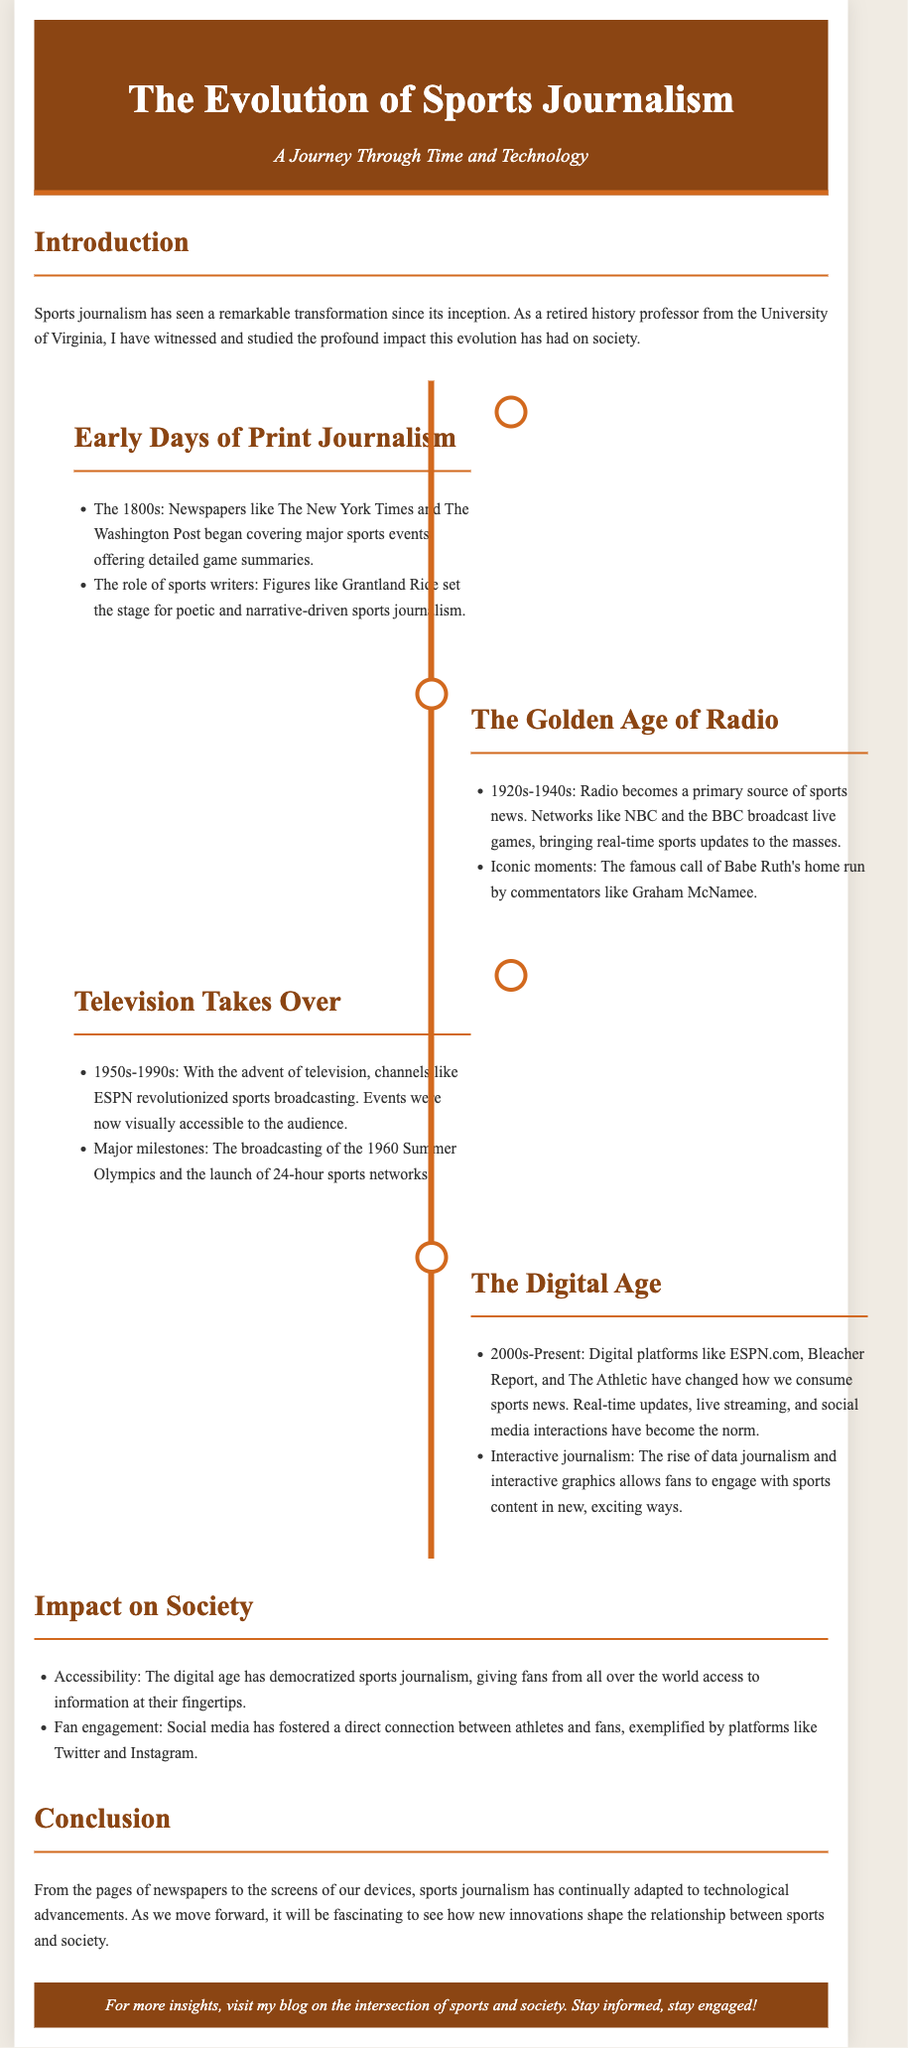What decade saw the rise of radio in sports journalism? The document states that the 1920s-1940s marked the period when radio became a primary source of sports news.
Answer: 1920s-1940s Who is noted for setting the stage for poetic sports journalism? The document mentions Grantland Rice as a key figure in early sports writing.
Answer: Grantland Rice What major event in sports journalism occurred with the advent of television? The document highlights the broadcasting of the 1960 Summer Olympics as a significant milestone.
Answer: 1960 Summer Olympics Which platforms have changed how we consume sports news in the digital age? The document lists ESPN.com, Bleacher Report, and The Athletic as examples of digital platforms.
Answer: ESPN.com, Bleacher Report, The Athletic What is one impact of the digital age on sports journalism? The document notes that the digital age has democratized sports journalism, making information more accessible.
Answer: Democratized accessibility What term describes the rise of data journalism in the digital age? The document uses the term "interactive journalism" to describe this phenomenon.
Answer: Interactive journalism What form of media primarily dominated sports journalism in the early 20th century? The document indicates that radio was a primary source of sports news during that time.
Answer: Radio Which two social media platforms are mentioned as fostering connection between athletes and fans? The document specifically mentions Twitter and Instagram as examples.
Answer: Twitter, Instagram What is the overall theme of the document? The document discusses the evolution of sports journalism from print to the digital age.
Answer: Evolution of sports journalism 